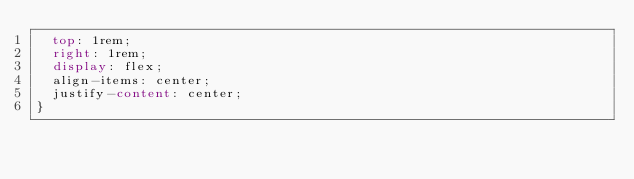Convert code to text. <code><loc_0><loc_0><loc_500><loc_500><_CSS_>  top: 1rem;
  right: 1rem;
  display: flex;
  align-items: center;
  justify-content: center;
} </code> 